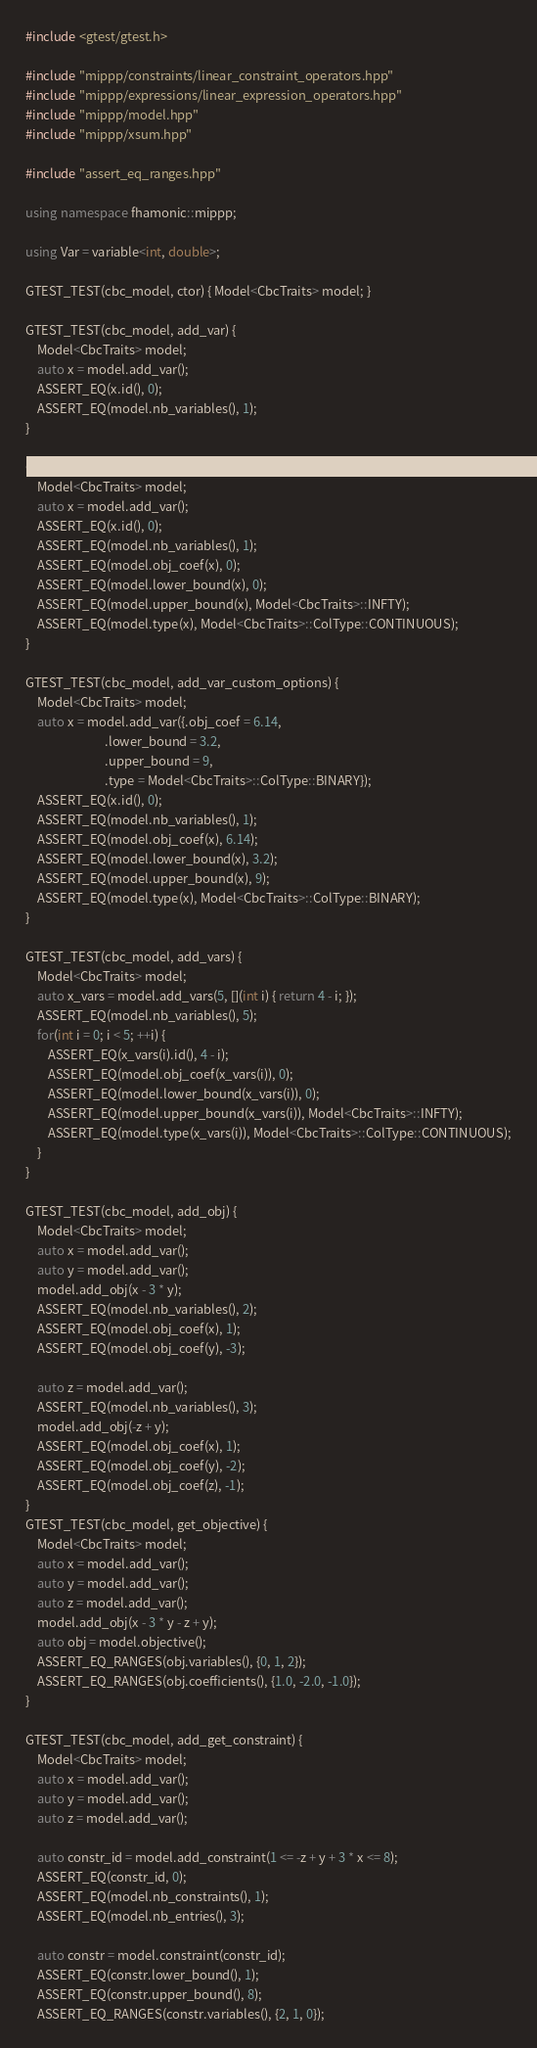Convert code to text. <code><loc_0><loc_0><loc_500><loc_500><_C++_>#include <gtest/gtest.h>

#include "mippp/constraints/linear_constraint_operators.hpp"
#include "mippp/expressions/linear_expression_operators.hpp"
#include "mippp/model.hpp"
#include "mippp/xsum.hpp"

#include "assert_eq_ranges.hpp"

using namespace fhamonic::mippp;

using Var = variable<int, double>;

GTEST_TEST(cbc_model, ctor) { Model<CbcTraits> model; }

GTEST_TEST(cbc_model, add_var) {
    Model<CbcTraits> model;
    auto x = model.add_var();
    ASSERT_EQ(x.id(), 0);
    ASSERT_EQ(model.nb_variables(), 1);
}

GTEST_TEST(cbc_model, add_var_default_options) {
    Model<CbcTraits> model;
    auto x = model.add_var();
    ASSERT_EQ(x.id(), 0);
    ASSERT_EQ(model.nb_variables(), 1);
    ASSERT_EQ(model.obj_coef(x), 0);
    ASSERT_EQ(model.lower_bound(x), 0);
    ASSERT_EQ(model.upper_bound(x), Model<CbcTraits>::INFTY);
    ASSERT_EQ(model.type(x), Model<CbcTraits>::ColType::CONTINUOUS);
}

GTEST_TEST(cbc_model, add_var_custom_options) {
    Model<CbcTraits> model;
    auto x = model.add_var({.obj_coef = 6.14,
                            .lower_bound = 3.2,
                            .upper_bound = 9,
                            .type = Model<CbcTraits>::ColType::BINARY});
    ASSERT_EQ(x.id(), 0);
    ASSERT_EQ(model.nb_variables(), 1);
    ASSERT_EQ(model.obj_coef(x), 6.14);
    ASSERT_EQ(model.lower_bound(x), 3.2);
    ASSERT_EQ(model.upper_bound(x), 9);
    ASSERT_EQ(model.type(x), Model<CbcTraits>::ColType::BINARY);
}

GTEST_TEST(cbc_model, add_vars) {
    Model<CbcTraits> model;
    auto x_vars = model.add_vars(5, [](int i) { return 4 - i; });
    ASSERT_EQ(model.nb_variables(), 5);
    for(int i = 0; i < 5; ++i) {
        ASSERT_EQ(x_vars(i).id(), 4 - i);
        ASSERT_EQ(model.obj_coef(x_vars(i)), 0);
        ASSERT_EQ(model.lower_bound(x_vars(i)), 0);
        ASSERT_EQ(model.upper_bound(x_vars(i)), Model<CbcTraits>::INFTY);
        ASSERT_EQ(model.type(x_vars(i)), Model<CbcTraits>::ColType::CONTINUOUS);
    }
}

GTEST_TEST(cbc_model, add_obj) {
    Model<CbcTraits> model;
    auto x = model.add_var();
    auto y = model.add_var();
    model.add_obj(x - 3 * y);
    ASSERT_EQ(model.nb_variables(), 2);
    ASSERT_EQ(model.obj_coef(x), 1);
    ASSERT_EQ(model.obj_coef(y), -3);

    auto z = model.add_var();
    ASSERT_EQ(model.nb_variables(), 3);
    model.add_obj(-z + y);
    ASSERT_EQ(model.obj_coef(x), 1);
    ASSERT_EQ(model.obj_coef(y), -2);
    ASSERT_EQ(model.obj_coef(z), -1);
}
GTEST_TEST(cbc_model, get_objective) {
    Model<CbcTraits> model;
    auto x = model.add_var();
    auto y = model.add_var();
    auto z = model.add_var();
    model.add_obj(x - 3 * y - z + y);
    auto obj = model.objective();
    ASSERT_EQ_RANGES(obj.variables(), {0, 1, 2});
    ASSERT_EQ_RANGES(obj.coefficients(), {1.0, -2.0, -1.0});
}

GTEST_TEST(cbc_model, add_get_constraint) {
    Model<CbcTraits> model;
    auto x = model.add_var();
    auto y = model.add_var();
    auto z = model.add_var();

    auto constr_id = model.add_constraint(1 <= -z + y + 3 * x <= 8);
    ASSERT_EQ(constr_id, 0);
    ASSERT_EQ(model.nb_constraints(), 1);
    ASSERT_EQ(model.nb_entries(), 3);

    auto constr = model.constraint(constr_id);
    ASSERT_EQ(constr.lower_bound(), 1);
    ASSERT_EQ(constr.upper_bound(), 8);
    ASSERT_EQ_RANGES(constr.variables(), {2, 1, 0});</code> 